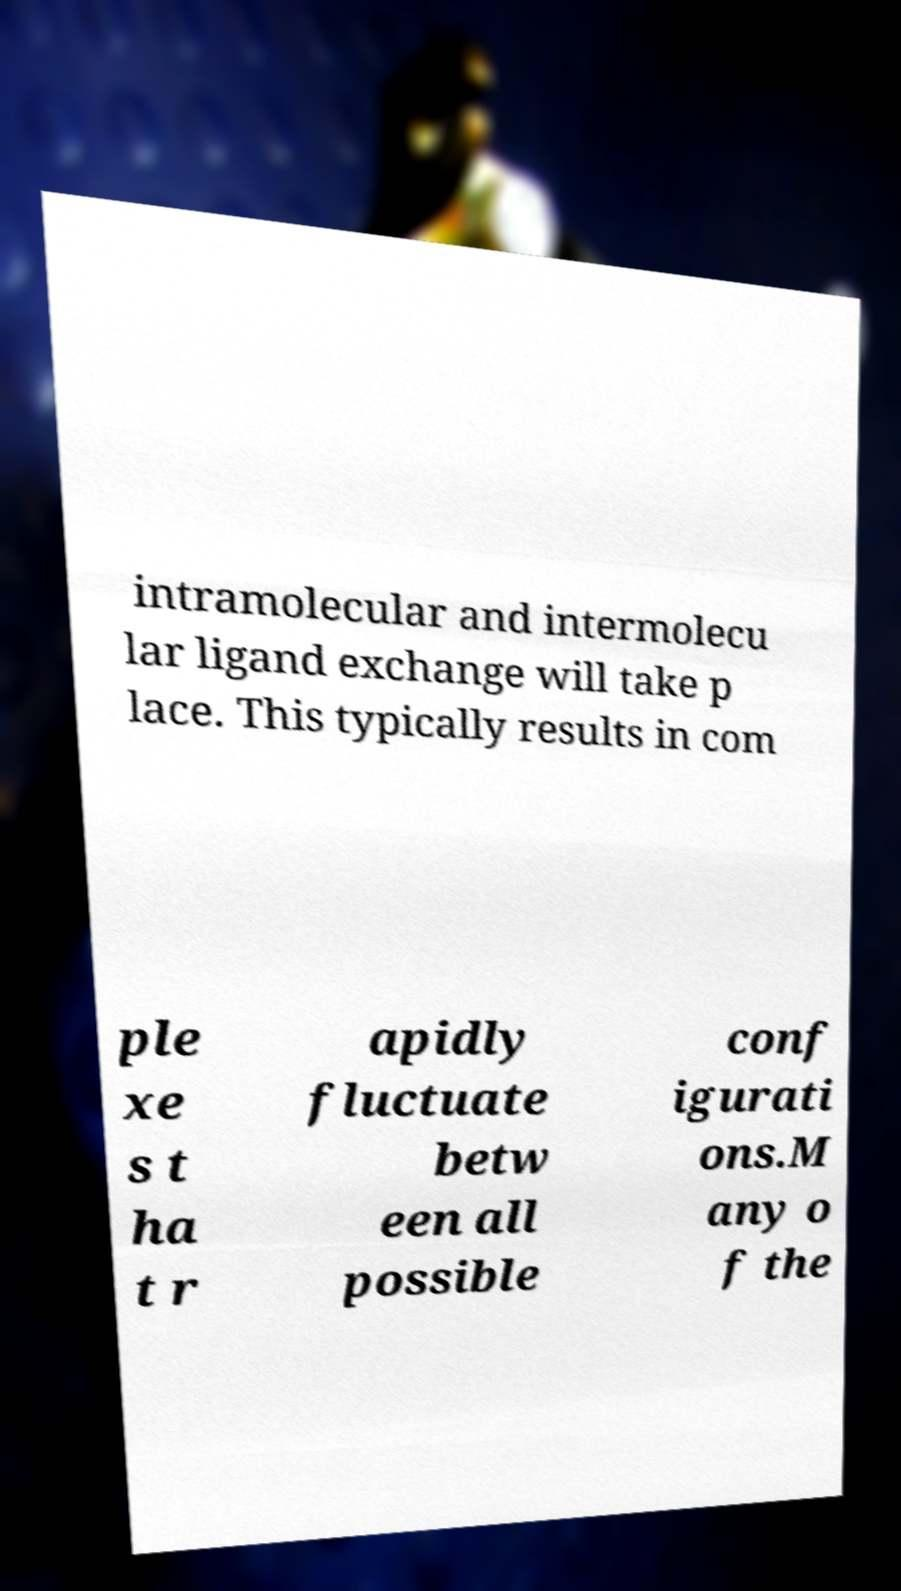There's text embedded in this image that I need extracted. Can you transcribe it verbatim? intramolecular and intermolecu lar ligand exchange will take p lace. This typically results in com ple xe s t ha t r apidly fluctuate betw een all possible conf igurati ons.M any o f the 